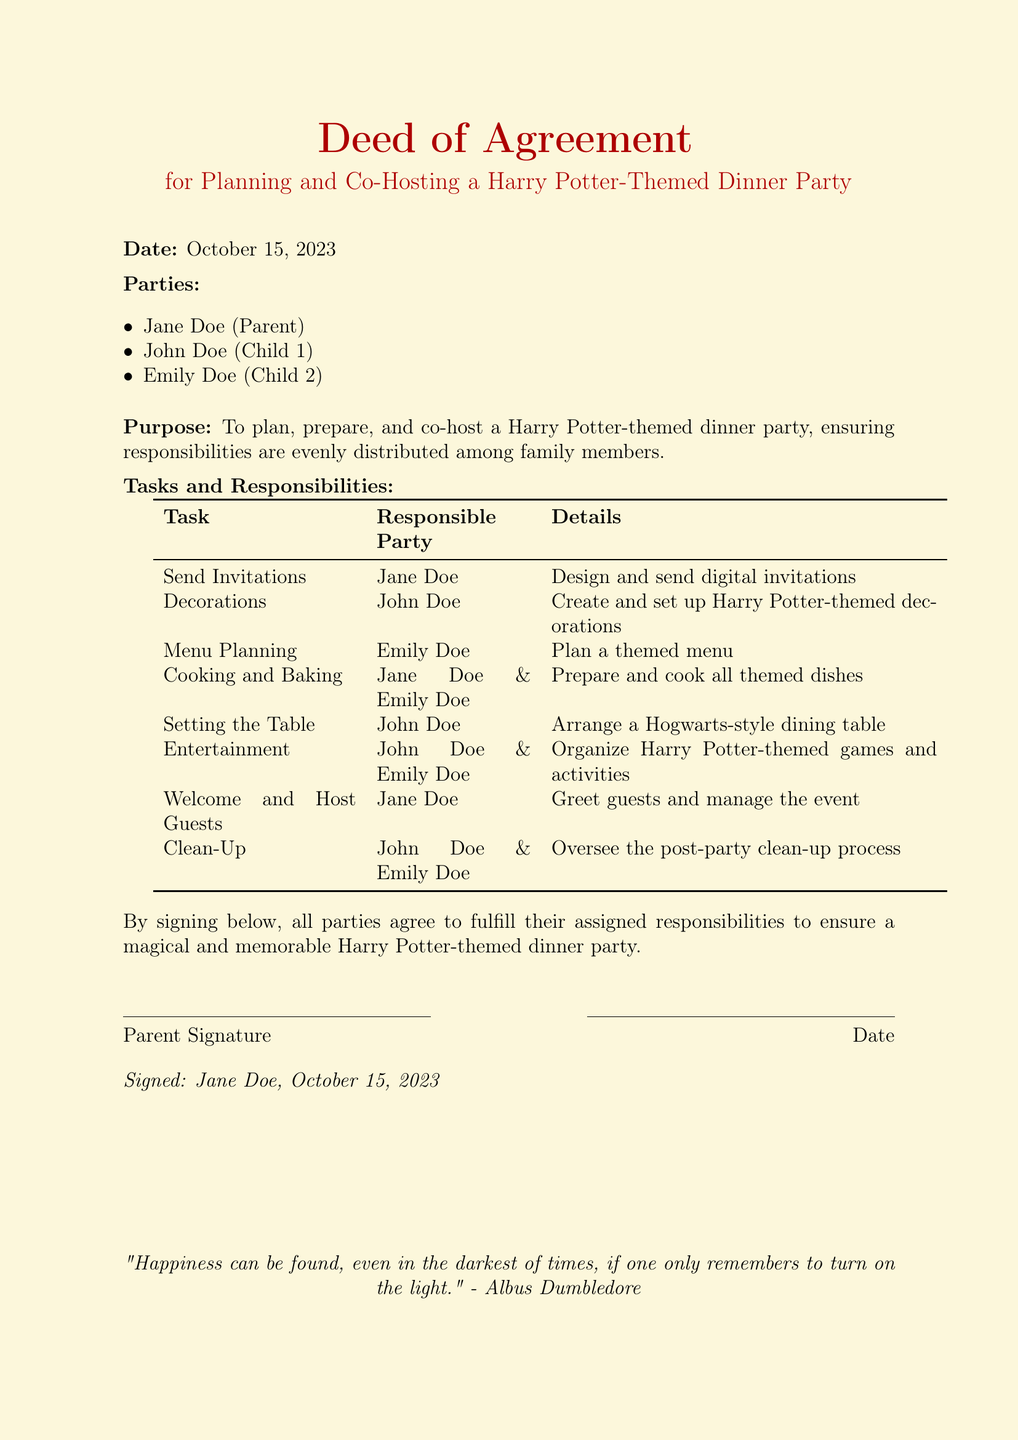What is the date of the agreement? The date is mentioned at the beginning of the document, which is October 15, 2023.
Answer: October 15, 2023 Who is responsible for sending invitations? The responsibilities are listed in a table, where Jane Doe is tasked with sending invitations.
Answer: Jane Doe What is the theme of the dinner party? The purpose of the document specifies that it is for a Harry Potter-themed dinner party.
Answer: Harry Potter How many family members are involved in the planning? The document lists three parties: Jane Doe, John Doe, and Emily Doe, indicating three family members.
Answer: Three What task is assigned to John Doe for the decorations? The specific task given to John Doe is to create and set up decorations.
Answer: Create and set up Harry Potter-themed decorations Who is responsible for cooking and baking? The document assigns cooking and baking duties to Jane Doe and Emily Doe.
Answer: Jane Doe & Emily Doe What is the last signature in the document? The document mentions the signer and the date, which includes only Jane Doe below the signature line.
Answer: Jane Doe, October 15, 2023 What quote is included at the bottom of the document? The document includes a quote by Albus Dumbledore, which reflects on finding happiness in dark times.
Answer: "Happiness can be found, even in the darkest of times, if one only remembers to turn on the light." - Albus Dumbledore 